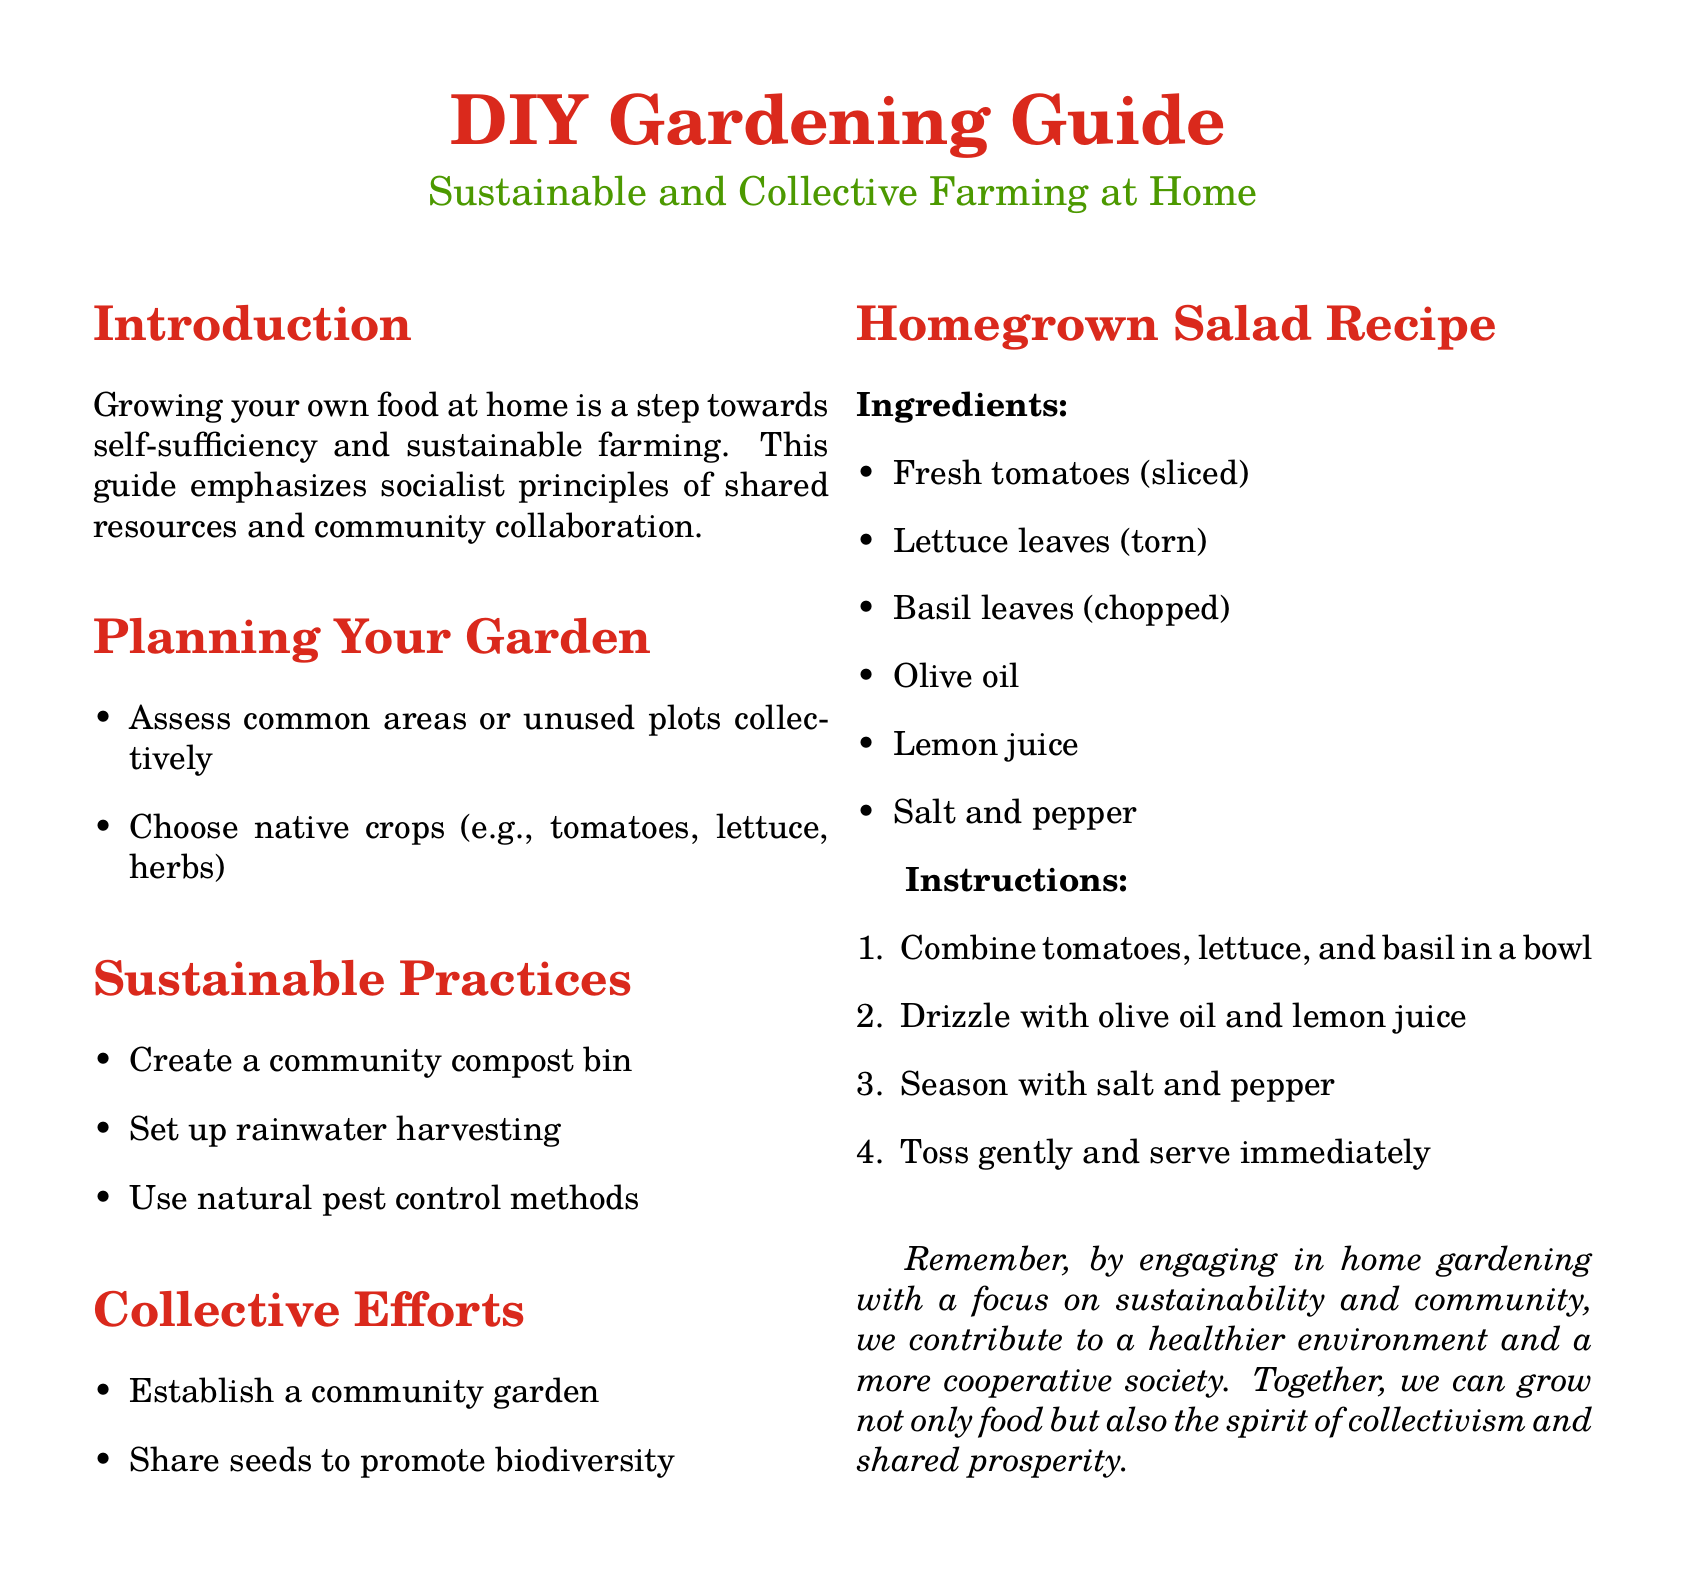What is the main theme of the guide? The main theme is self-sufficiency and sustainable farming, emphasizing socialist principles.
Answer: Sustainable farming What is one method mentioned for pest control? This can be found under sustainable practices that focus on natural methods.
Answer: Natural pest control What type of crops should be chosen for the garden? The guide specifies a preferred type of crops in the planning section.
Answer: Native crops How many ingredients are listed in the salad recipe? This can be determined by counting the items under the recipe section.
Answer: Six ingredients What is a suggested collective effort in gardening? The document lists a few collective efforts under that specific section.
Answer: Community garden What is the primary purpose of a community compost bin? This relates to sustainable practices mentioned in the guide.
Answer: Composting Which herb is included in the homegrown salad? The answer can be found in the ingredients list for the salad recipe.
Answer: Basil leaves 